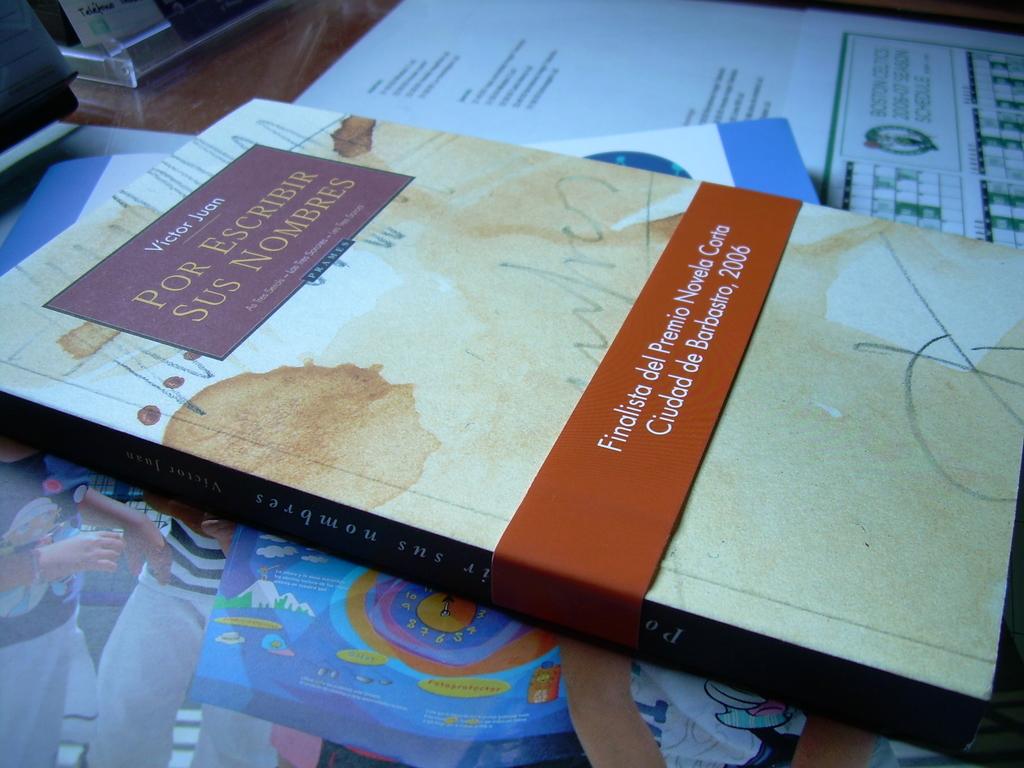What language is this book?
Make the answer very short. Spanish. 